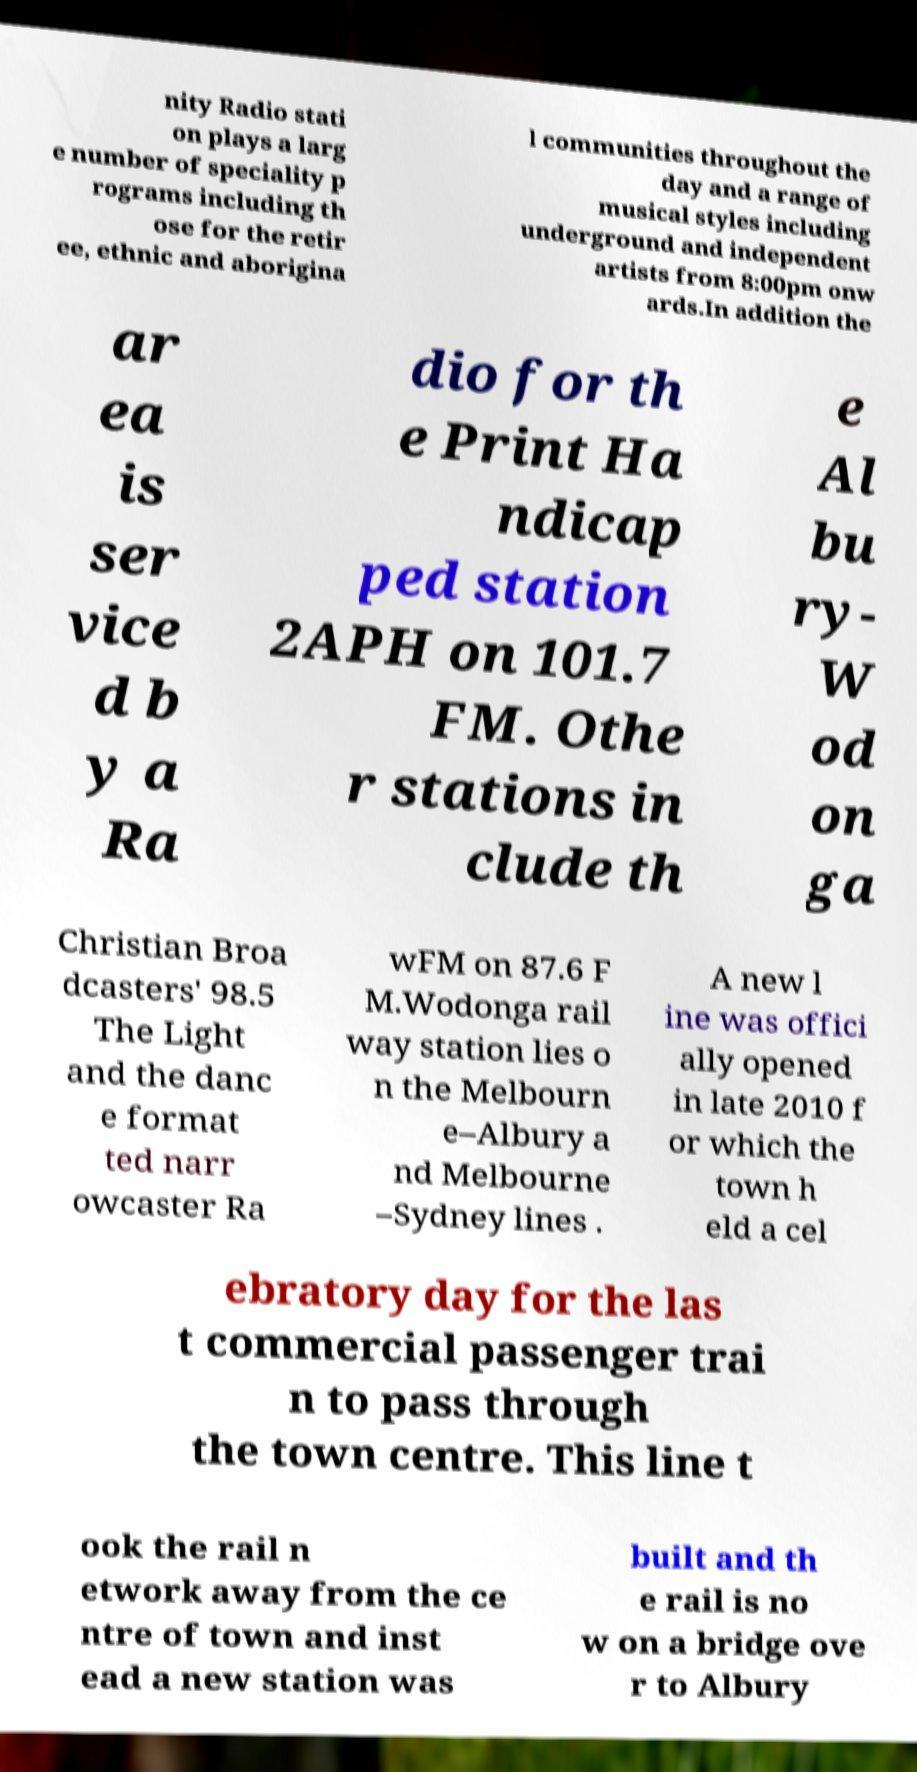Please identify and transcribe the text found in this image. nity Radio stati on plays a larg e number of speciality p rograms including th ose for the retir ee, ethnic and aborigina l communities throughout the day and a range of musical styles including underground and independent artists from 8:00pm onw ards.In addition the ar ea is ser vice d b y a Ra dio for th e Print Ha ndicap ped station 2APH on 101.7 FM. Othe r stations in clude th e Al bu ry- W od on ga Christian Broa dcasters' 98.5 The Light and the danc e format ted narr owcaster Ra wFM on 87.6 F M.Wodonga rail way station lies o n the Melbourn e–Albury a nd Melbourne –Sydney lines . A new l ine was offici ally opened in late 2010 f or which the town h eld a cel ebratory day for the las t commercial passenger trai n to pass through the town centre. This line t ook the rail n etwork away from the ce ntre of town and inst ead a new station was built and th e rail is no w on a bridge ove r to Albury 